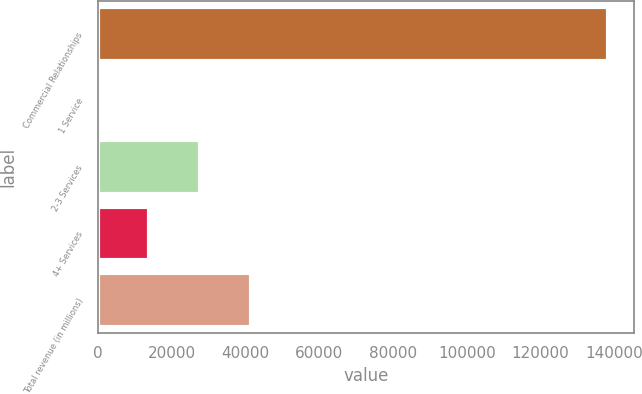Convert chart to OTSL. <chart><loc_0><loc_0><loc_500><loc_500><bar_chart><fcel>Commercial Relationships<fcel>1 Service<fcel>2-3 Services<fcel>4+ Services<fcel>Total revenue (in millions)<nl><fcel>138357<fcel>28.4<fcel>27694.1<fcel>13861.3<fcel>41527<nl></chart> 